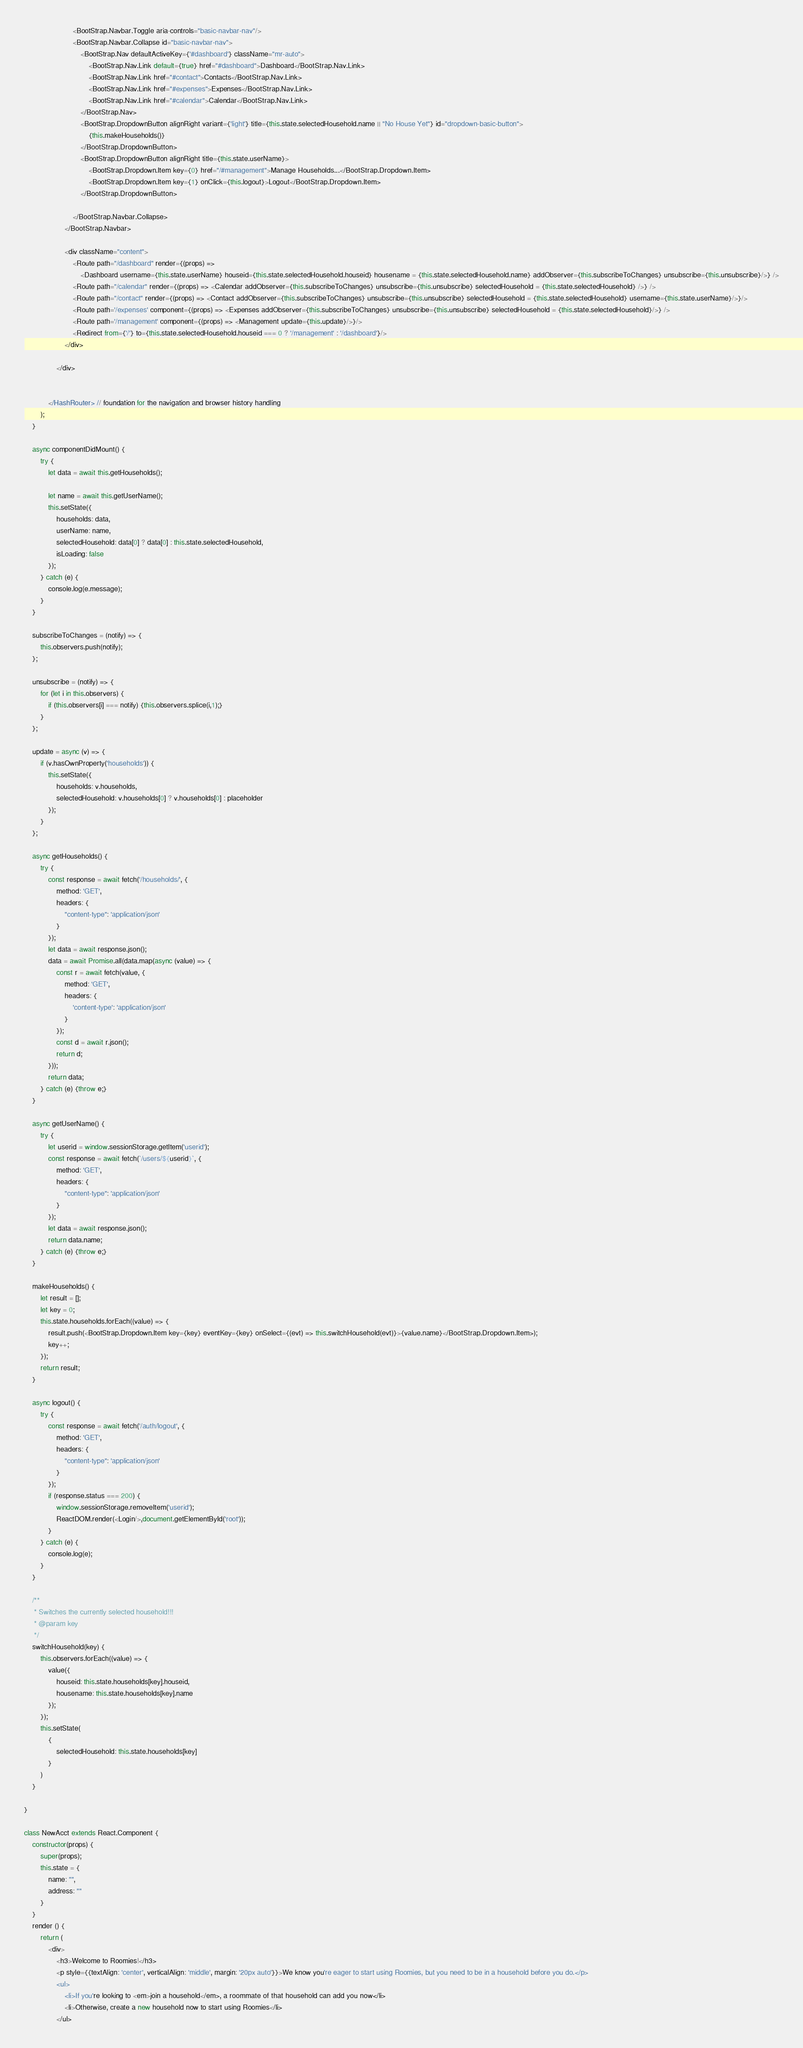<code> <loc_0><loc_0><loc_500><loc_500><_JavaScript_>                        <BootStrap.Navbar.Toggle aria-controls="basic-navbar-nav"/>
                        <BootStrap.Navbar.Collapse id="basic-navbar-nav">
                            <BootStrap.Nav defaultActiveKey={'#dashboard'} className="mr-auto">
                                <BootStrap.Nav.Link default={true} href="#dashboard">Dashboard</BootStrap.Nav.Link>
                                <BootStrap.Nav.Link href="#contact">Contacts</BootStrap.Nav.Link>
                                <BootStrap.Nav.Link href="#expenses">Expenses</BootStrap.Nav.Link>
                                <BootStrap.Nav.Link href="#calendar">Calendar</BootStrap.Nav.Link>
                            </BootStrap.Nav>
                            <BootStrap.DropdownButton alignRight variant={'light'} title={this.state.selectedHousehold.name || "No House Yet"} id="dropdown-basic-button">
                                {this.makeHouseholds()}
                            </BootStrap.DropdownButton>
                            <BootStrap.DropdownButton alignRight title={this.state.userName}>
                                <BootStrap.Dropdown.Item key={0} href="/#management">Manage Households...</BootStrap.Dropdown.Item>
                                <BootStrap.Dropdown.Item key={1} onClick={this.logout}>Logout</BootStrap.Dropdown.Item>
                            </BootStrap.DropdownButton>

                        </BootStrap.Navbar.Collapse>
                    </BootStrap.Navbar>

                    <div className="content">
                        <Route path="/dashboard" render={(props) =>
                            <Dashboard username={this.state.userName} houseid={this.state.selectedHousehold.houseid} housename = {this.state.selectedHousehold.name} addObserver={this.subscribeToChanges} unsubscribe={this.unsubscribe}/>} />
                        <Route path="/calendar" render={(props) => <Calendar addObserver={this.subscribeToChanges} unsubscribe={this.unsubscribe} selectedHousehold = {this.state.selectedHousehold} />} />
                        <Route path="/contact" render={(props) => <Contact addObserver={this.subscribeToChanges} unsubscribe={this.unsubscribe} selectedHousehold = {this.state.selectedHousehold} username={this.state.userName}/>}/>
                        <Route path='/expenses' component={(props) => <Expenses addObserver={this.subscribeToChanges} unsubscribe={this.unsubscribe} selectedHousehold = {this.state.selectedHousehold}/>} />
                        <Route path='/management' component={(props) => <Management update={this.update}/>}/>
                        <Redirect from={'/'} to={this.state.selectedHousehold.houseid === 0 ? '/management' : '/dashboard'}/>
                    </div>

                </div>


            </HashRouter> // foundation for the navigation and browser history handling
        );
    }

    async componentDidMount() {
        try {
            let data = await this.getHouseholds();

            let name = await this.getUserName();
            this.setState({
                households: data,
                userName: name,
                selectedHousehold: data[0] ? data[0] : this.state.selectedHousehold,
                isLoading: false
            });
        } catch (e) {
            console.log(e.message);
        }
    }

    subscribeToChanges = (notify) => {
        this.observers.push(notify);
    };

    unsubscribe = (notify) => {
        for (let i in this.observers) {
            if (this.observers[i] === notify) {this.observers.splice(i,1);}
        }
    };

    update = async (v) => {
        if (v.hasOwnProperty('households')) {
            this.setState({
                households: v.households,
                selectedHousehold: v.households[0] ? v.households[0] : placeholder
            });
        }
    };

    async getHouseholds() {
        try {
            const response = await fetch('/households/', {
                method: 'GET',
                headers: {
                    "content-type": 'application/json'
                }
            });
            let data = await response.json();
            data = await Promise.all(data.map(async (value) => {
                const r = await fetch(value, {
                    method: 'GET',
                    headers: {
                        'content-type': 'application/json'
                    }
                });
                const d = await r.json();
                return d;
            }));
            return data;
        } catch (e) {throw e;}
    }

    async getUserName() {
        try {
            let userid = window.sessionStorage.getItem('userid');
            const response = await fetch(`/users/${userid}`, {
                method: 'GET',
                headers: {
                    "content-type": 'application/json'
                }
            });
            let data = await response.json();
            return data.name;
        } catch (e) {throw e;}
    }

    makeHouseholds() {
        let result = [];
        let key = 0;
        this.state.households.forEach((value) => {
            result.push(<BootStrap.Dropdown.Item key={key} eventKey={key} onSelect={(evt) => this.switchHousehold(evt)}>{value.name}</BootStrap.Dropdown.Item>);
            key++;
        });
        return result;
    }

    async logout() {
        try {
            const response = await fetch('/auth/logout', {
                method: 'GET',
                headers: {
                    "content-type": 'application/json'
                }
            });
            if (response.status === 200) {
                window.sessionStorage.removeItem('userid');
                ReactDOM.render(<Login/>,document.getElementById('root'));
            }
        } catch (e) {
            console.log(e);
        }
    }

    /**
     * Switches the currently selected household!!!
     * @param key
     */
    switchHousehold(key) {
        this.observers.forEach((value) => {
            value({
                houseid: this.state.households[key].houseid,
                housename: this.state.households[key].name
            });
        });
        this.setState(
            {
                selectedHousehold: this.state.households[key]
            }
        )
    }

}

class NewAcct extends React.Component {
    constructor(props) {
        super(props);
        this.state = {
            name: "",
            address: ""
        }
    }
    render () {
        return (
            <div>
                <h3>Welcome to Roomies!</h3>
                <p style={{textAlign: 'center', verticalAlign: 'middle', margin: '20px auto'}}>We know you're eager to start using Roomies, but you need to be in a household before you do.</p>
                <ul>
                    <li>If you're looking to <em>join a household</em>, a roommate of that household can add you now</li>
                    <li>Otherwise, create a new household now to start using Roomies</li>
                </ul></code> 